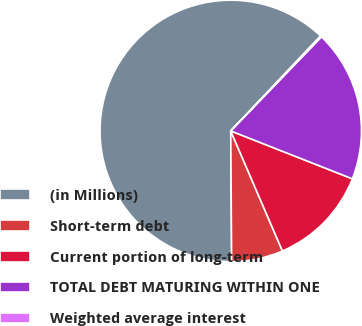<chart> <loc_0><loc_0><loc_500><loc_500><pie_chart><fcel>(in Millions)<fcel>Short-term debt<fcel>Current portion of long-term<fcel>TOTAL DEBT MATURING WITHIN ONE<fcel>Weighted average interest<nl><fcel>62.17%<fcel>6.36%<fcel>12.56%<fcel>18.76%<fcel>0.15%<nl></chart> 